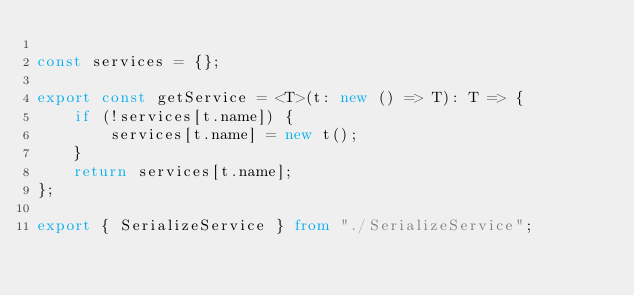Convert code to text. <code><loc_0><loc_0><loc_500><loc_500><_TypeScript_>
const services = {};

export const getService = <T>(t: new () => T): T => {
    if (!services[t.name]) {
        services[t.name] = new t();
    }
    return services[t.name];
};

export { SerializeService } from "./SerializeService";</code> 